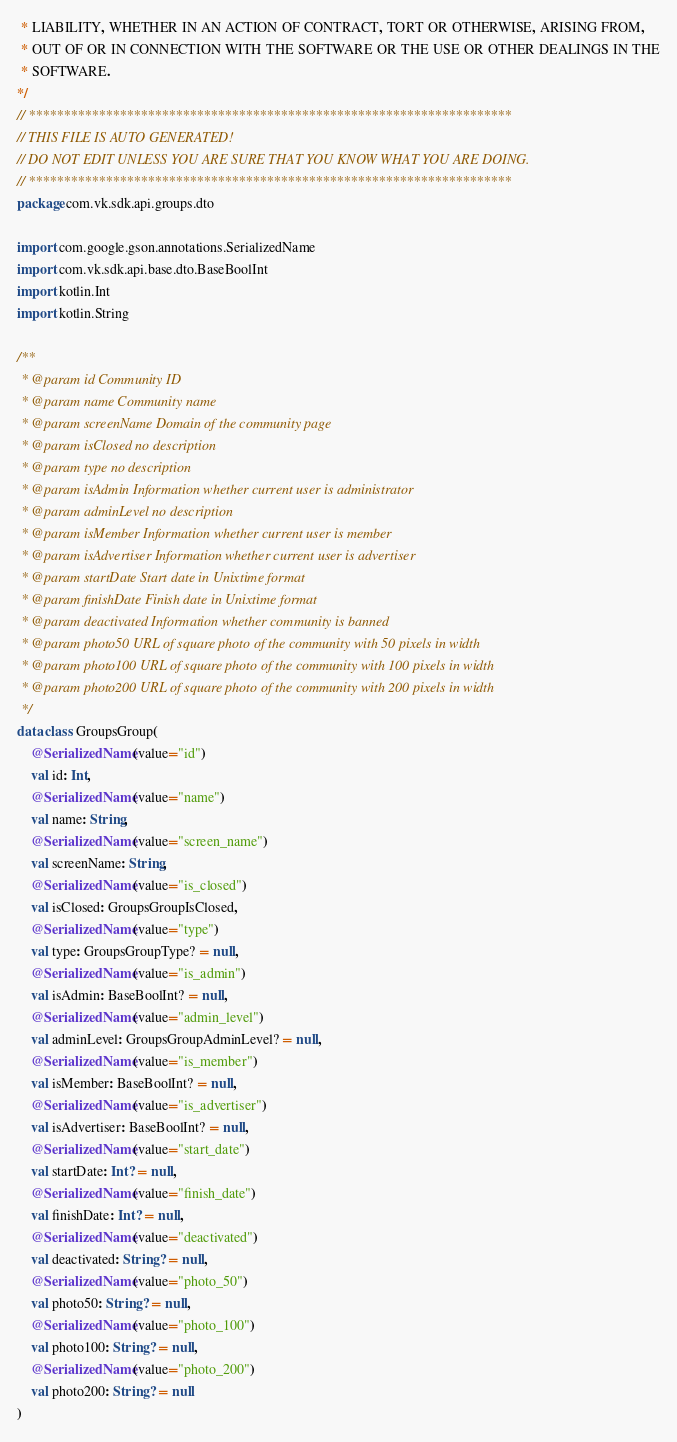<code> <loc_0><loc_0><loc_500><loc_500><_Kotlin_> * LIABILITY, WHETHER IN AN ACTION OF CONTRACT, TORT OR OTHERWISE, ARISING FROM,
 * OUT OF OR IN CONNECTION WITH THE SOFTWARE OR THE USE OR OTHER DEALINGS IN THE
 * SOFTWARE.
*/
// *********************************************************************
// THIS FILE IS AUTO GENERATED!
// DO NOT EDIT UNLESS YOU ARE SURE THAT YOU KNOW WHAT YOU ARE DOING.
// *********************************************************************
package com.vk.sdk.api.groups.dto

import com.google.gson.annotations.SerializedName
import com.vk.sdk.api.base.dto.BaseBoolInt
import kotlin.Int
import kotlin.String

/**
 * @param id Community ID
 * @param name Community name
 * @param screenName Domain of the community page
 * @param isClosed no description
 * @param type no description
 * @param isAdmin Information whether current user is administrator
 * @param adminLevel no description
 * @param isMember Information whether current user is member
 * @param isAdvertiser Information whether current user is advertiser
 * @param startDate Start date in Unixtime format
 * @param finishDate Finish date in Unixtime format
 * @param deactivated Information whether community is banned
 * @param photo50 URL of square photo of the community with 50 pixels in width
 * @param photo100 URL of square photo of the community with 100 pixels in width
 * @param photo200 URL of square photo of the community with 200 pixels in width
 */
data class GroupsGroup(
    @SerializedName(value="id")
    val id: Int,
    @SerializedName(value="name")
    val name: String,
    @SerializedName(value="screen_name")
    val screenName: String,
    @SerializedName(value="is_closed")
    val isClosed: GroupsGroupIsClosed,
    @SerializedName(value="type")
    val type: GroupsGroupType? = null,
    @SerializedName(value="is_admin")
    val isAdmin: BaseBoolInt? = null,
    @SerializedName(value="admin_level")
    val adminLevel: GroupsGroupAdminLevel? = null,
    @SerializedName(value="is_member")
    val isMember: BaseBoolInt? = null,
    @SerializedName(value="is_advertiser")
    val isAdvertiser: BaseBoolInt? = null,
    @SerializedName(value="start_date")
    val startDate: Int? = null,
    @SerializedName(value="finish_date")
    val finishDate: Int? = null,
    @SerializedName(value="deactivated")
    val deactivated: String? = null,
    @SerializedName(value="photo_50")
    val photo50: String? = null,
    @SerializedName(value="photo_100")
    val photo100: String? = null,
    @SerializedName(value="photo_200")
    val photo200: String? = null
)
</code> 